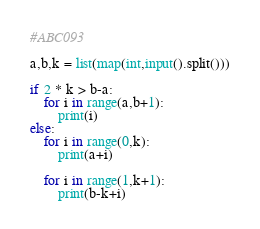Convert code to text. <code><loc_0><loc_0><loc_500><loc_500><_Python_>#ABC093

a,b,k = list(map(int,input().split()))

if 2 * k > b-a:
    for i in range(a,b+1):
        print(i)
else:
    for i in range(0,k):
        print(a+i)
    
    for i in range(1,k+1):
        print(b-k+i)

</code> 